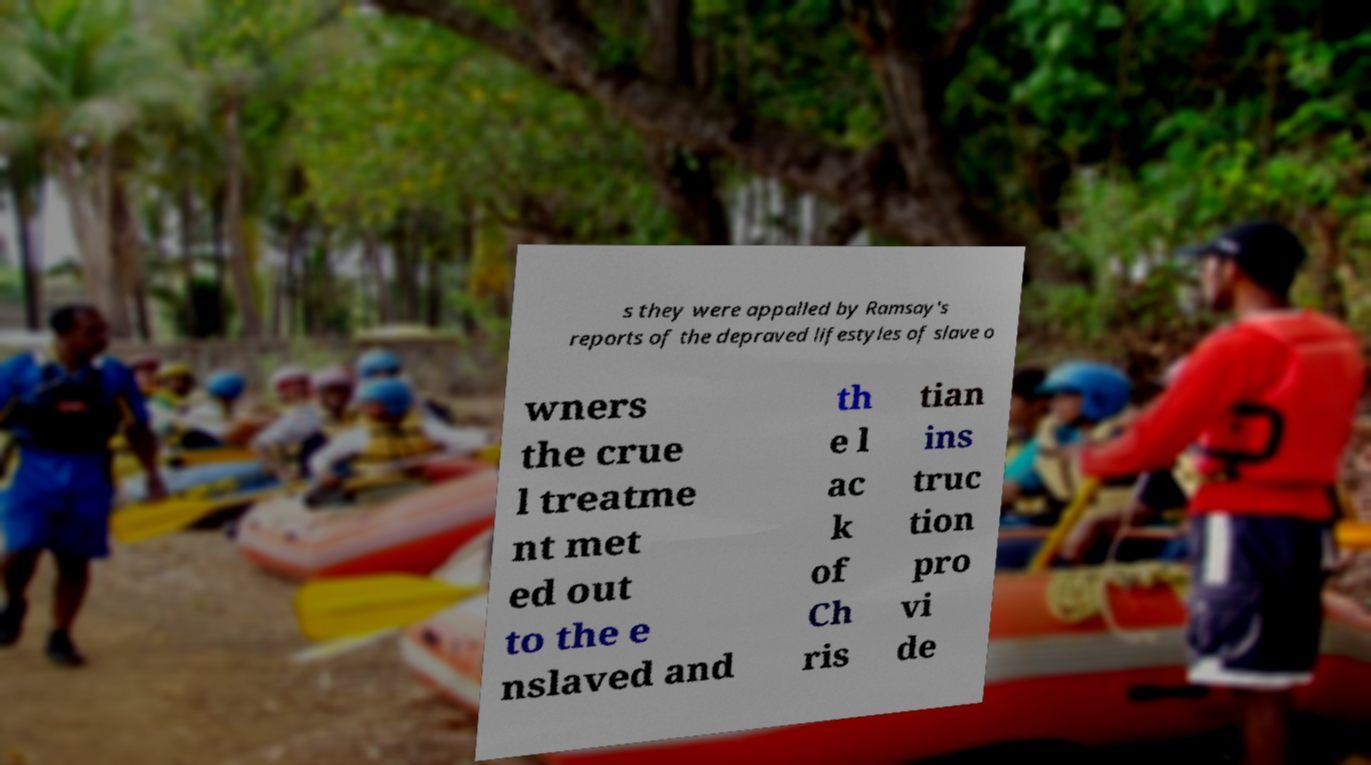I need the written content from this picture converted into text. Can you do that? s they were appalled by Ramsay's reports of the depraved lifestyles of slave o wners the crue l treatme nt met ed out to the e nslaved and th e l ac k of Ch ris tian ins truc tion pro vi de 